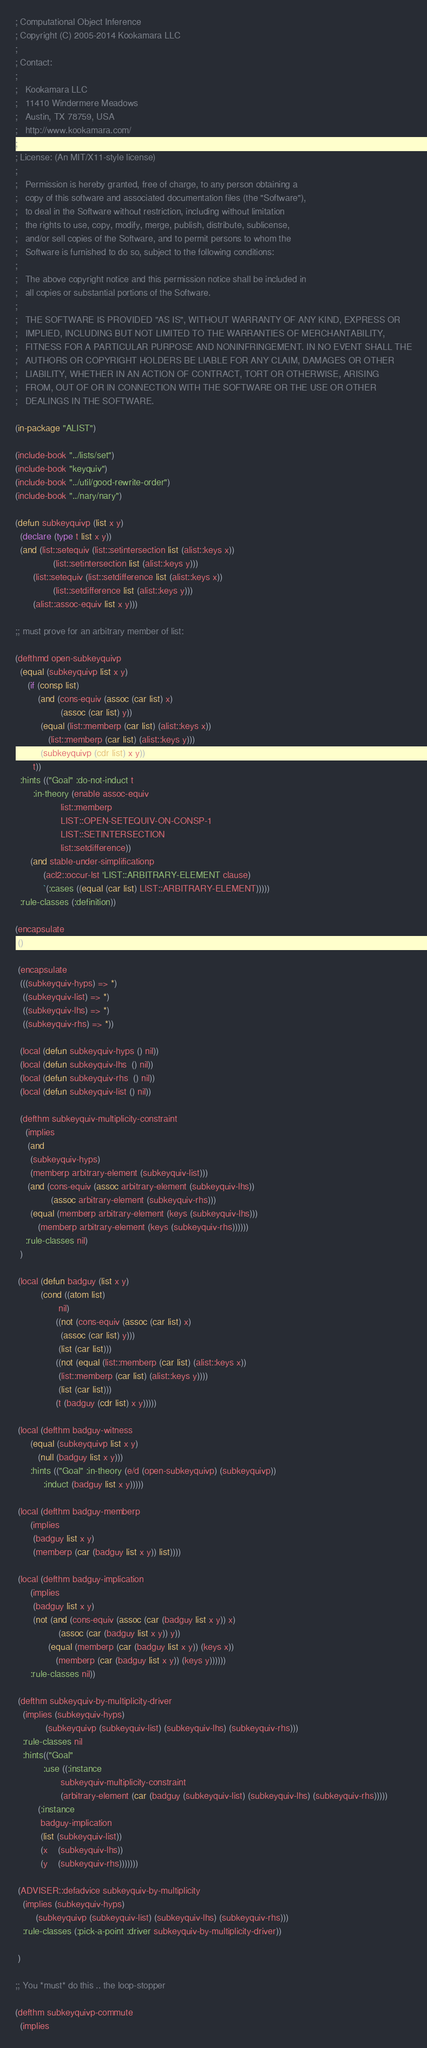<code> <loc_0><loc_0><loc_500><loc_500><_Lisp_>; Computational Object Inference
; Copyright (C) 2005-2014 Kookamara LLC
;
; Contact:
;
;   Kookamara LLC
;   11410 Windermere Meadows
;   Austin, TX 78759, USA
;   http://www.kookamara.com/
;
; License: (An MIT/X11-style license)
;
;   Permission is hereby granted, free of charge, to any person obtaining a
;   copy of this software and associated documentation files (the "Software"),
;   to deal in the Software without restriction, including without limitation
;   the rights to use, copy, modify, merge, publish, distribute, sublicense,
;   and/or sell copies of the Software, and to permit persons to whom the
;   Software is furnished to do so, subject to the following conditions:
;
;   The above copyright notice and this permission notice shall be included in
;   all copies or substantial portions of the Software.
;
;   THE SOFTWARE IS PROVIDED "AS IS", WITHOUT WARRANTY OF ANY KIND, EXPRESS OR
;   IMPLIED, INCLUDING BUT NOT LIMITED TO THE WARRANTIES OF MERCHANTABILITY,
;   FITNESS FOR A PARTICULAR PURPOSE AND NONINFRINGEMENT. IN NO EVENT SHALL THE
;   AUTHORS OR COPYRIGHT HOLDERS BE LIABLE FOR ANY CLAIM, DAMAGES OR OTHER
;   LIABILITY, WHETHER IN AN ACTION OF CONTRACT, TORT OR OTHERWISE, ARISING
;   FROM, OUT OF OR IN CONNECTION WITH THE SOFTWARE OR THE USE OR OTHER
;   DEALINGS IN THE SOFTWARE.

(in-package "ALIST")

(include-book "../lists/set")
(include-book "keyquiv")
(include-book "../util/good-rewrite-order")
(include-book "../nary/nary")

(defun subkeyquivp (list x y)
  (declare (type t list x y))
  (and (list::setequiv (list::setintersection list (alist::keys x))
		       (list::setintersection list (alist::keys y)))
       (list::setequiv (list::setdifference list (alist::keys x))
		       (list::setdifference list (alist::keys y)))
       (alist::assoc-equiv list x y)))

;; must prove for an arbitrary member of list:

(defthmd open-subkeyquivp
  (equal (subkeyquivp list x y)
	 (if (consp list)
	     (and (cons-equiv (assoc (car list) x)
			      (assoc (car list) y))
		  (equal (list::memberp (car list) (alist::keys x))
			 (list::memberp (car list) (alist::keys y)))
		  (subkeyquivp (cdr list) x y))
	   t))
  :hints (("Goal" :do-not-induct t
	   :in-theory (enable assoc-equiv
			      list::memberp
			      LIST::OPEN-SETEQUIV-ON-CONSP-1
			      LIST::SETINTERSECTION
			      list::setdifference))
	  (and stable-under-simplificationp
	       (acl2::occur-lst 'LIST::ARBITRARY-ELEMENT clause)
	       `(:cases ((equal (car list) LIST::ARBITRARY-ELEMENT)))))
  :rule-classes (:definition))

(encapsulate
 ()

 (encapsulate
  (((subkeyquiv-hyps) => *)
   ((subkeyquiv-list) => *)
   ((subkeyquiv-lhs) => *)
   ((subkeyquiv-rhs) => *))

  (local (defun subkeyquiv-hyps () nil))
  (local (defun subkeyquiv-lhs  () nil))
  (local (defun subkeyquiv-rhs  () nil))
  (local (defun subkeyquiv-list () nil))

  (defthm subkeyquiv-multiplicity-constraint
    (implies
     (and
      (subkeyquiv-hyps)
      (memberp arbitrary-element (subkeyquiv-list)))
     (and (cons-equiv (assoc arbitrary-element (subkeyquiv-lhs))
		      (assoc arbitrary-element (subkeyquiv-rhs)))
	  (equal (memberp arbitrary-element (keys (subkeyquiv-lhs)))
		 (memberp arbitrary-element (keys (subkeyquiv-rhs))))))
    :rule-classes nil)
  )

 (local (defun badguy (list x y)
          (cond ((atom list)
                 nil)
                ((not (cons-equiv (assoc (car list) x)
				  (assoc (car list) y)))
                 (list (car list)))
                ((not (equal (list::memberp (car list) (alist::keys x))
			     (list::memberp (car list) (alist::keys y))))
                 (list (car list)))
                (t (badguy (cdr list) x y)))))

 (local (defthm badguy-witness
	  (equal (subkeyquivp list x y)
		 (null (badguy list x y)))
	  :hints (("Goal" :in-theory (e/d (open-subkeyquivp) (subkeyquivp))
		   :induct (badguy list x y)))))

 (local (defthm badguy-memberp
	  (implies
	   (badguy list x y)
	   (memberp (car (badguy list x y)) list))))

 (local (defthm badguy-implication
	  (implies
	   (badguy list x y)
	   (not (and (cons-equiv (assoc (car (badguy list x y)) x)
				 (assoc (car (badguy list x y)) y))
		     (equal (memberp (car (badguy list x y)) (keys x))
			    (memberp (car (badguy list x y)) (keys y))))))
	  :rule-classes nil))

 (defthm subkeyquiv-by-multiplicity-driver
   (implies (subkeyquiv-hyps)
            (subkeyquivp (subkeyquiv-list) (subkeyquiv-lhs) (subkeyquiv-rhs)))
   :rule-classes nil
   :hints(("Goal"
           :use ((:instance
                  subkeyquiv-multiplicity-constraint
                  (arbitrary-element (car (badguy (subkeyquiv-list) (subkeyquiv-lhs) (subkeyquiv-rhs)))))
		 (:instance
		  badguy-implication
		  (list (subkeyquiv-list))
		  (x    (subkeyquiv-lhs))
		  (y    (subkeyquiv-rhs)))))))

 (ADVISER::defadvice subkeyquiv-by-multiplicity
   (implies (subkeyquiv-hyps)
	    (subkeyquivp (subkeyquiv-list) (subkeyquiv-lhs) (subkeyquiv-rhs)))
   :rule-classes (:pick-a-point :driver subkeyquiv-by-multiplicity-driver))

 )

;; You *must* do this .. the loop-stopper

(defthm subkeyquivp-commute
  (implies</code> 